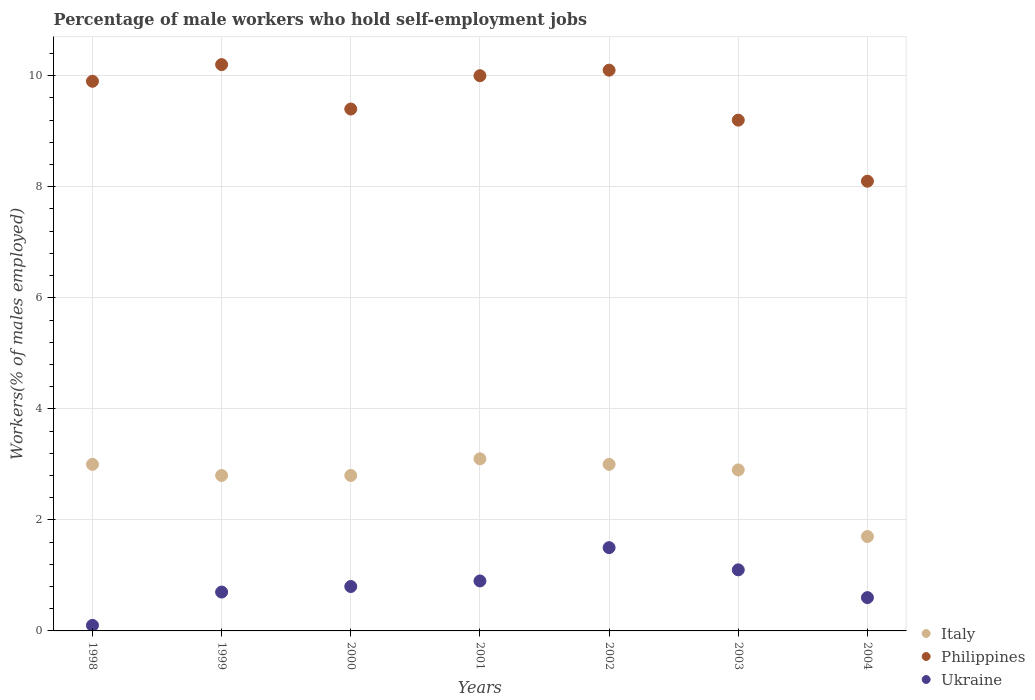Is the number of dotlines equal to the number of legend labels?
Make the answer very short. Yes. What is the percentage of self-employed male workers in Italy in 2004?
Your response must be concise. 1.7. Across all years, what is the maximum percentage of self-employed male workers in Philippines?
Your answer should be compact. 10.2. Across all years, what is the minimum percentage of self-employed male workers in Ukraine?
Your answer should be very brief. 0.1. What is the total percentage of self-employed male workers in Philippines in the graph?
Your response must be concise. 66.9. What is the difference between the percentage of self-employed male workers in Ukraine in 1999 and that in 2002?
Offer a terse response. -0.8. What is the difference between the percentage of self-employed male workers in Philippines in 2002 and the percentage of self-employed male workers in Italy in 2001?
Ensure brevity in your answer.  7. What is the average percentage of self-employed male workers in Italy per year?
Keep it short and to the point. 2.76. In the year 2004, what is the difference between the percentage of self-employed male workers in Ukraine and percentage of self-employed male workers in Italy?
Make the answer very short. -1.1. What is the ratio of the percentage of self-employed male workers in Philippines in 2001 to that in 2002?
Your answer should be compact. 0.99. What is the difference between the highest and the second highest percentage of self-employed male workers in Philippines?
Keep it short and to the point. 0.1. What is the difference between the highest and the lowest percentage of self-employed male workers in Italy?
Provide a succinct answer. 1.4. What is the difference between two consecutive major ticks on the Y-axis?
Give a very brief answer. 2. Does the graph contain any zero values?
Ensure brevity in your answer.  No. What is the title of the graph?
Make the answer very short. Percentage of male workers who hold self-employment jobs. What is the label or title of the X-axis?
Your answer should be very brief. Years. What is the label or title of the Y-axis?
Offer a very short reply. Workers(% of males employed). What is the Workers(% of males employed) of Philippines in 1998?
Offer a very short reply. 9.9. What is the Workers(% of males employed) in Ukraine in 1998?
Keep it short and to the point. 0.1. What is the Workers(% of males employed) of Italy in 1999?
Make the answer very short. 2.8. What is the Workers(% of males employed) of Philippines in 1999?
Your answer should be compact. 10.2. What is the Workers(% of males employed) in Ukraine in 1999?
Ensure brevity in your answer.  0.7. What is the Workers(% of males employed) in Italy in 2000?
Offer a very short reply. 2.8. What is the Workers(% of males employed) of Philippines in 2000?
Offer a very short reply. 9.4. What is the Workers(% of males employed) of Ukraine in 2000?
Your answer should be compact. 0.8. What is the Workers(% of males employed) in Italy in 2001?
Offer a terse response. 3.1. What is the Workers(% of males employed) in Philippines in 2001?
Offer a terse response. 10. What is the Workers(% of males employed) of Ukraine in 2001?
Your answer should be very brief. 0.9. What is the Workers(% of males employed) in Italy in 2002?
Your response must be concise. 3. What is the Workers(% of males employed) of Philippines in 2002?
Keep it short and to the point. 10.1. What is the Workers(% of males employed) of Italy in 2003?
Offer a terse response. 2.9. What is the Workers(% of males employed) of Philippines in 2003?
Offer a very short reply. 9.2. What is the Workers(% of males employed) in Ukraine in 2003?
Provide a short and direct response. 1.1. What is the Workers(% of males employed) of Italy in 2004?
Your response must be concise. 1.7. What is the Workers(% of males employed) in Philippines in 2004?
Provide a succinct answer. 8.1. What is the Workers(% of males employed) in Ukraine in 2004?
Provide a succinct answer. 0.6. Across all years, what is the maximum Workers(% of males employed) in Italy?
Your answer should be compact. 3.1. Across all years, what is the maximum Workers(% of males employed) in Philippines?
Make the answer very short. 10.2. Across all years, what is the maximum Workers(% of males employed) of Ukraine?
Make the answer very short. 1.5. Across all years, what is the minimum Workers(% of males employed) of Italy?
Offer a very short reply. 1.7. Across all years, what is the minimum Workers(% of males employed) of Philippines?
Provide a succinct answer. 8.1. Across all years, what is the minimum Workers(% of males employed) of Ukraine?
Keep it short and to the point. 0.1. What is the total Workers(% of males employed) of Italy in the graph?
Keep it short and to the point. 19.3. What is the total Workers(% of males employed) of Philippines in the graph?
Offer a terse response. 66.9. What is the total Workers(% of males employed) in Ukraine in the graph?
Keep it short and to the point. 5.7. What is the difference between the Workers(% of males employed) of Italy in 1998 and that in 1999?
Provide a short and direct response. 0.2. What is the difference between the Workers(% of males employed) in Philippines in 1998 and that in 1999?
Your response must be concise. -0.3. What is the difference between the Workers(% of males employed) in Philippines in 1998 and that in 2000?
Keep it short and to the point. 0.5. What is the difference between the Workers(% of males employed) in Philippines in 1998 and that in 2001?
Ensure brevity in your answer.  -0.1. What is the difference between the Workers(% of males employed) of Italy in 1998 and that in 2002?
Make the answer very short. 0. What is the difference between the Workers(% of males employed) in Italy in 1998 and that in 2004?
Provide a succinct answer. 1.3. What is the difference between the Workers(% of males employed) in Ukraine in 1998 and that in 2004?
Ensure brevity in your answer.  -0.5. What is the difference between the Workers(% of males employed) of Philippines in 1999 and that in 2000?
Your response must be concise. 0.8. What is the difference between the Workers(% of males employed) in Philippines in 1999 and that in 2001?
Give a very brief answer. 0.2. What is the difference between the Workers(% of males employed) in Italy in 1999 and that in 2002?
Offer a terse response. -0.2. What is the difference between the Workers(% of males employed) in Italy in 1999 and that in 2003?
Your answer should be compact. -0.1. What is the difference between the Workers(% of males employed) of Italy in 2000 and that in 2002?
Give a very brief answer. -0.2. What is the difference between the Workers(% of males employed) in Ukraine in 2000 and that in 2002?
Provide a short and direct response. -0.7. What is the difference between the Workers(% of males employed) in Italy in 2000 and that in 2003?
Your answer should be very brief. -0.1. What is the difference between the Workers(% of males employed) in Philippines in 2000 and that in 2003?
Provide a short and direct response. 0.2. What is the difference between the Workers(% of males employed) of Ukraine in 2000 and that in 2003?
Your answer should be compact. -0.3. What is the difference between the Workers(% of males employed) in Ukraine in 2000 and that in 2004?
Keep it short and to the point. 0.2. What is the difference between the Workers(% of males employed) in Italy in 2001 and that in 2003?
Ensure brevity in your answer.  0.2. What is the difference between the Workers(% of males employed) in Italy in 2001 and that in 2004?
Offer a very short reply. 1.4. What is the difference between the Workers(% of males employed) in Italy in 2002 and that in 2003?
Make the answer very short. 0.1. What is the difference between the Workers(% of males employed) of Ukraine in 2002 and that in 2003?
Make the answer very short. 0.4. What is the difference between the Workers(% of males employed) of Italy in 2002 and that in 2004?
Make the answer very short. 1.3. What is the difference between the Workers(% of males employed) in Philippines in 2002 and that in 2004?
Offer a very short reply. 2. What is the difference between the Workers(% of males employed) in Italy in 2003 and that in 2004?
Your answer should be compact. 1.2. What is the difference between the Workers(% of males employed) of Philippines in 2003 and that in 2004?
Offer a terse response. 1.1. What is the difference between the Workers(% of males employed) in Ukraine in 2003 and that in 2004?
Provide a succinct answer. 0.5. What is the difference between the Workers(% of males employed) of Italy in 1998 and the Workers(% of males employed) of Ukraine in 1999?
Offer a very short reply. 2.3. What is the difference between the Workers(% of males employed) of Philippines in 1998 and the Workers(% of males employed) of Ukraine in 1999?
Make the answer very short. 9.2. What is the difference between the Workers(% of males employed) in Italy in 1998 and the Workers(% of males employed) in Ukraine in 2000?
Provide a short and direct response. 2.2. What is the difference between the Workers(% of males employed) in Italy in 1998 and the Workers(% of males employed) in Philippines in 2001?
Provide a short and direct response. -7. What is the difference between the Workers(% of males employed) in Philippines in 1998 and the Workers(% of males employed) in Ukraine in 2001?
Provide a short and direct response. 9. What is the difference between the Workers(% of males employed) in Italy in 1998 and the Workers(% of males employed) in Philippines in 2002?
Your response must be concise. -7.1. What is the difference between the Workers(% of males employed) in Philippines in 1998 and the Workers(% of males employed) in Ukraine in 2003?
Your answer should be compact. 8.8. What is the difference between the Workers(% of males employed) in Italy in 1998 and the Workers(% of males employed) in Ukraine in 2004?
Provide a short and direct response. 2.4. What is the difference between the Workers(% of males employed) of Italy in 1999 and the Workers(% of males employed) of Philippines in 2000?
Your response must be concise. -6.6. What is the difference between the Workers(% of males employed) of Italy in 1999 and the Workers(% of males employed) of Ukraine in 2000?
Give a very brief answer. 2. What is the difference between the Workers(% of males employed) in Philippines in 1999 and the Workers(% of males employed) in Ukraine in 2000?
Provide a short and direct response. 9.4. What is the difference between the Workers(% of males employed) of Italy in 1999 and the Workers(% of males employed) of Ukraine in 2001?
Give a very brief answer. 1.9. What is the difference between the Workers(% of males employed) in Italy in 1999 and the Workers(% of males employed) in Ukraine in 2002?
Provide a succinct answer. 1.3. What is the difference between the Workers(% of males employed) of Philippines in 1999 and the Workers(% of males employed) of Ukraine in 2002?
Your answer should be compact. 8.7. What is the difference between the Workers(% of males employed) in Italy in 1999 and the Workers(% of males employed) in Ukraine in 2003?
Your response must be concise. 1.7. What is the difference between the Workers(% of males employed) in Philippines in 1999 and the Workers(% of males employed) in Ukraine in 2004?
Your answer should be very brief. 9.6. What is the difference between the Workers(% of males employed) in Italy in 2000 and the Workers(% of males employed) in Ukraine in 2001?
Your response must be concise. 1.9. What is the difference between the Workers(% of males employed) of Italy in 2000 and the Workers(% of males employed) of Philippines in 2002?
Give a very brief answer. -7.3. What is the difference between the Workers(% of males employed) of Italy in 2000 and the Workers(% of males employed) of Ukraine in 2002?
Your answer should be very brief. 1.3. What is the difference between the Workers(% of males employed) of Italy in 2000 and the Workers(% of males employed) of Ukraine in 2003?
Offer a terse response. 1.7. What is the difference between the Workers(% of males employed) of Italy in 2000 and the Workers(% of males employed) of Ukraine in 2004?
Provide a short and direct response. 2.2. What is the difference between the Workers(% of males employed) in Italy in 2001 and the Workers(% of males employed) in Philippines in 2002?
Make the answer very short. -7. What is the difference between the Workers(% of males employed) of Italy in 2001 and the Workers(% of males employed) of Ukraine in 2002?
Give a very brief answer. 1.6. What is the difference between the Workers(% of males employed) of Italy in 2001 and the Workers(% of males employed) of Ukraine in 2003?
Provide a succinct answer. 2. What is the difference between the Workers(% of males employed) of Philippines in 2001 and the Workers(% of males employed) of Ukraine in 2003?
Your answer should be compact. 8.9. What is the difference between the Workers(% of males employed) of Italy in 2001 and the Workers(% of males employed) of Ukraine in 2004?
Provide a succinct answer. 2.5. What is the difference between the Workers(% of males employed) in Italy in 2002 and the Workers(% of males employed) in Philippines in 2003?
Your answer should be compact. -6.2. What is the difference between the Workers(% of males employed) of Italy in 2002 and the Workers(% of males employed) of Ukraine in 2003?
Make the answer very short. 1.9. What is the difference between the Workers(% of males employed) of Philippines in 2002 and the Workers(% of males employed) of Ukraine in 2003?
Give a very brief answer. 9. What is the difference between the Workers(% of males employed) of Italy in 2002 and the Workers(% of males employed) of Ukraine in 2004?
Provide a short and direct response. 2.4. What is the difference between the Workers(% of males employed) of Philippines in 2002 and the Workers(% of males employed) of Ukraine in 2004?
Offer a very short reply. 9.5. What is the difference between the Workers(% of males employed) in Philippines in 2003 and the Workers(% of males employed) in Ukraine in 2004?
Ensure brevity in your answer.  8.6. What is the average Workers(% of males employed) in Italy per year?
Offer a terse response. 2.76. What is the average Workers(% of males employed) of Philippines per year?
Give a very brief answer. 9.56. What is the average Workers(% of males employed) in Ukraine per year?
Give a very brief answer. 0.81. In the year 1998, what is the difference between the Workers(% of males employed) in Italy and Workers(% of males employed) in Philippines?
Provide a succinct answer. -6.9. In the year 1998, what is the difference between the Workers(% of males employed) in Italy and Workers(% of males employed) in Ukraine?
Your response must be concise. 2.9. In the year 1999, what is the difference between the Workers(% of males employed) in Italy and Workers(% of males employed) in Philippines?
Provide a succinct answer. -7.4. In the year 1999, what is the difference between the Workers(% of males employed) in Italy and Workers(% of males employed) in Ukraine?
Make the answer very short. 2.1. In the year 2000, what is the difference between the Workers(% of males employed) in Italy and Workers(% of males employed) in Philippines?
Ensure brevity in your answer.  -6.6. In the year 2001, what is the difference between the Workers(% of males employed) in Italy and Workers(% of males employed) in Ukraine?
Give a very brief answer. 2.2. In the year 2001, what is the difference between the Workers(% of males employed) of Philippines and Workers(% of males employed) of Ukraine?
Your answer should be very brief. 9.1. In the year 2002, what is the difference between the Workers(% of males employed) in Philippines and Workers(% of males employed) in Ukraine?
Keep it short and to the point. 8.6. In the year 2003, what is the difference between the Workers(% of males employed) in Italy and Workers(% of males employed) in Philippines?
Your answer should be compact. -6.3. In the year 2003, what is the difference between the Workers(% of males employed) of Philippines and Workers(% of males employed) of Ukraine?
Give a very brief answer. 8.1. In the year 2004, what is the difference between the Workers(% of males employed) in Italy and Workers(% of males employed) in Philippines?
Make the answer very short. -6.4. In the year 2004, what is the difference between the Workers(% of males employed) of Italy and Workers(% of males employed) of Ukraine?
Offer a terse response. 1.1. What is the ratio of the Workers(% of males employed) of Italy in 1998 to that in 1999?
Your answer should be very brief. 1.07. What is the ratio of the Workers(% of males employed) of Philippines in 1998 to that in 1999?
Your answer should be very brief. 0.97. What is the ratio of the Workers(% of males employed) of Ukraine in 1998 to that in 1999?
Offer a terse response. 0.14. What is the ratio of the Workers(% of males employed) of Italy in 1998 to that in 2000?
Make the answer very short. 1.07. What is the ratio of the Workers(% of males employed) of Philippines in 1998 to that in 2000?
Keep it short and to the point. 1.05. What is the ratio of the Workers(% of males employed) of Italy in 1998 to that in 2001?
Provide a short and direct response. 0.97. What is the ratio of the Workers(% of males employed) of Philippines in 1998 to that in 2001?
Give a very brief answer. 0.99. What is the ratio of the Workers(% of males employed) of Ukraine in 1998 to that in 2001?
Make the answer very short. 0.11. What is the ratio of the Workers(% of males employed) of Philippines in 1998 to that in 2002?
Your answer should be compact. 0.98. What is the ratio of the Workers(% of males employed) of Ukraine in 1998 to that in 2002?
Offer a terse response. 0.07. What is the ratio of the Workers(% of males employed) in Italy in 1998 to that in 2003?
Offer a terse response. 1.03. What is the ratio of the Workers(% of males employed) of Philippines in 1998 to that in 2003?
Give a very brief answer. 1.08. What is the ratio of the Workers(% of males employed) of Ukraine in 1998 to that in 2003?
Provide a succinct answer. 0.09. What is the ratio of the Workers(% of males employed) in Italy in 1998 to that in 2004?
Offer a terse response. 1.76. What is the ratio of the Workers(% of males employed) of Philippines in 1998 to that in 2004?
Offer a very short reply. 1.22. What is the ratio of the Workers(% of males employed) in Ukraine in 1998 to that in 2004?
Your answer should be very brief. 0.17. What is the ratio of the Workers(% of males employed) in Philippines in 1999 to that in 2000?
Ensure brevity in your answer.  1.09. What is the ratio of the Workers(% of males employed) in Ukraine in 1999 to that in 2000?
Offer a very short reply. 0.88. What is the ratio of the Workers(% of males employed) of Italy in 1999 to that in 2001?
Provide a succinct answer. 0.9. What is the ratio of the Workers(% of males employed) in Philippines in 1999 to that in 2002?
Your answer should be compact. 1.01. What is the ratio of the Workers(% of males employed) in Ukraine in 1999 to that in 2002?
Provide a succinct answer. 0.47. What is the ratio of the Workers(% of males employed) in Italy in 1999 to that in 2003?
Make the answer very short. 0.97. What is the ratio of the Workers(% of males employed) of Philippines in 1999 to that in 2003?
Your response must be concise. 1.11. What is the ratio of the Workers(% of males employed) in Ukraine in 1999 to that in 2003?
Your answer should be compact. 0.64. What is the ratio of the Workers(% of males employed) in Italy in 1999 to that in 2004?
Offer a terse response. 1.65. What is the ratio of the Workers(% of males employed) in Philippines in 1999 to that in 2004?
Your answer should be very brief. 1.26. What is the ratio of the Workers(% of males employed) of Ukraine in 1999 to that in 2004?
Ensure brevity in your answer.  1.17. What is the ratio of the Workers(% of males employed) of Italy in 2000 to that in 2001?
Your answer should be compact. 0.9. What is the ratio of the Workers(% of males employed) of Italy in 2000 to that in 2002?
Keep it short and to the point. 0.93. What is the ratio of the Workers(% of males employed) of Philippines in 2000 to that in 2002?
Offer a very short reply. 0.93. What is the ratio of the Workers(% of males employed) of Ukraine in 2000 to that in 2002?
Offer a terse response. 0.53. What is the ratio of the Workers(% of males employed) in Italy in 2000 to that in 2003?
Your answer should be compact. 0.97. What is the ratio of the Workers(% of males employed) of Philippines in 2000 to that in 2003?
Your answer should be compact. 1.02. What is the ratio of the Workers(% of males employed) in Ukraine in 2000 to that in 2003?
Offer a very short reply. 0.73. What is the ratio of the Workers(% of males employed) in Italy in 2000 to that in 2004?
Your response must be concise. 1.65. What is the ratio of the Workers(% of males employed) of Philippines in 2000 to that in 2004?
Provide a short and direct response. 1.16. What is the ratio of the Workers(% of males employed) in Italy in 2001 to that in 2003?
Offer a terse response. 1.07. What is the ratio of the Workers(% of males employed) of Philippines in 2001 to that in 2003?
Offer a very short reply. 1.09. What is the ratio of the Workers(% of males employed) in Ukraine in 2001 to that in 2003?
Provide a succinct answer. 0.82. What is the ratio of the Workers(% of males employed) of Italy in 2001 to that in 2004?
Your answer should be compact. 1.82. What is the ratio of the Workers(% of males employed) in Philippines in 2001 to that in 2004?
Offer a terse response. 1.23. What is the ratio of the Workers(% of males employed) in Italy in 2002 to that in 2003?
Your response must be concise. 1.03. What is the ratio of the Workers(% of males employed) of Philippines in 2002 to that in 2003?
Provide a succinct answer. 1.1. What is the ratio of the Workers(% of males employed) of Ukraine in 2002 to that in 2003?
Your answer should be compact. 1.36. What is the ratio of the Workers(% of males employed) of Italy in 2002 to that in 2004?
Keep it short and to the point. 1.76. What is the ratio of the Workers(% of males employed) of Philippines in 2002 to that in 2004?
Your answer should be very brief. 1.25. What is the ratio of the Workers(% of males employed) in Italy in 2003 to that in 2004?
Offer a very short reply. 1.71. What is the ratio of the Workers(% of males employed) in Philippines in 2003 to that in 2004?
Provide a succinct answer. 1.14. What is the ratio of the Workers(% of males employed) in Ukraine in 2003 to that in 2004?
Your answer should be very brief. 1.83. What is the difference between the highest and the second highest Workers(% of males employed) in Italy?
Your answer should be compact. 0.1. What is the difference between the highest and the second highest Workers(% of males employed) of Philippines?
Make the answer very short. 0.1. What is the difference between the highest and the second highest Workers(% of males employed) in Ukraine?
Make the answer very short. 0.4. What is the difference between the highest and the lowest Workers(% of males employed) of Philippines?
Keep it short and to the point. 2.1. 